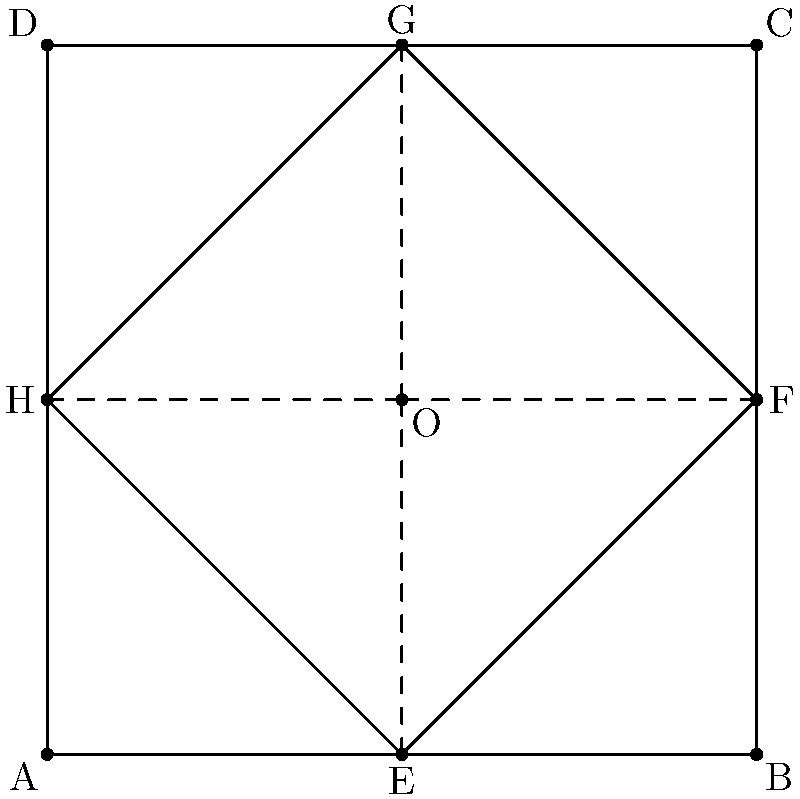As a startup co-founder designing a symmetrical logo for your travel platform, you decide to use transformational geometry. The initial design is a square ABCD with a rotated square EFGH inside, as shown in the figure. If you reflect triangle OEF across the line OG to create a complete logo design, what will be the area of the resulting shape as a fraction of the area of the outer square ABCD? Let's approach this step-by-step:

1) First, we need to understand what the question is asking. We're reflecting triangle OEF across line OG to complete the logo design.

2) The outer square ABCD has side length 2 units (as we can see from the coordinates). So its area is $A_{ABCD} = 2^2 = 4$ square units.

3) The inner square EFGH is rotated 45° and its diagonal is equal to the side of the outer square. So its side length is $\frac{2}{\sqrt{2}} = \sqrt{2}$ units.

4) Triangle OEF is a right-angled triangle. Its base OE is half the side of the outer square, so it's 1 unit. Its height EF is half the side of the inner square, so it's $\frac{\sqrt{2}}{2}$ units.

5) The area of triangle OEF is:

   $A_{OEF} = \frac{1}{2} \times 1 \times \frac{\sqrt{2}}{2} = \frac{\sqrt{2}}{4}$ square units

6) When we reflect OEF across OG, we create an identical triangle. So the total area of the two triangles is:

   $A_{total} = 2 \times \frac{\sqrt{2}}{4} = \frac{\sqrt{2}}{2}$ square units

7) This area as a fraction of the outer square's area is:

   $\frac{A_{total}}{A_{ABCD}} = \frac{\frac{\sqrt{2}}{2}}{4} = \frac{\sqrt{2}}{8}$

Therefore, the area of the resulting shape (two reflected triangles) is $\frac{\sqrt{2}}{8}$ of the area of the outer square ABCD.
Answer: $\frac{\sqrt{2}}{8}$ 